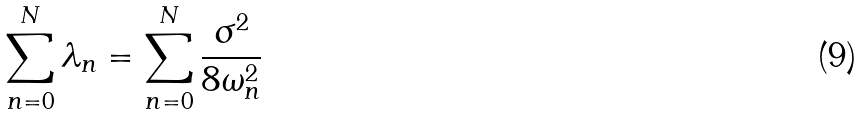Convert formula to latex. <formula><loc_0><loc_0><loc_500><loc_500>\sum _ { n = 0 } ^ { N } \lambda _ { n } = \sum _ { n = 0 } ^ { N } \frac { \sigma ^ { 2 } } { 8 \omega _ { n } ^ { 2 } }</formula> 